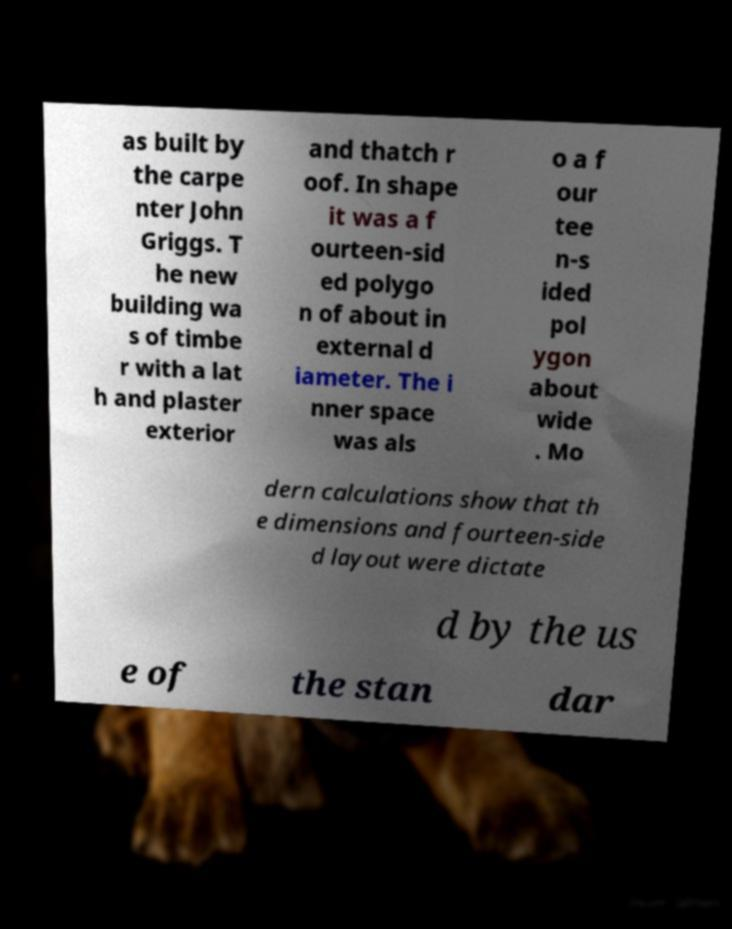What messages or text are displayed in this image? I need them in a readable, typed format. as built by the carpe nter John Griggs. T he new building wa s of timbe r with a lat h and plaster exterior and thatch r oof. In shape it was a f ourteen-sid ed polygo n of about in external d iameter. The i nner space was als o a f our tee n-s ided pol ygon about wide . Mo dern calculations show that th e dimensions and fourteen-side d layout were dictate d by the us e of the stan dar 